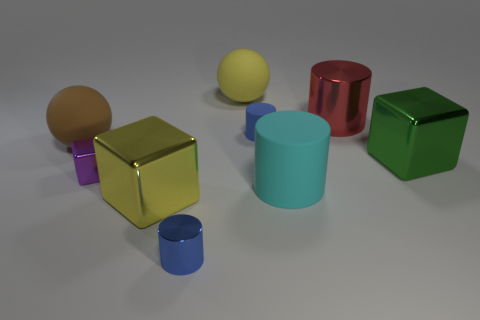Subtract all green metal cubes. How many cubes are left? 2 Subtract all blue cylinders. How many cylinders are left? 2 Subtract 3 cylinders. How many cylinders are left? 1 Subtract all yellow cylinders. Subtract all blue cubes. How many cylinders are left? 4 Subtract all blue cubes. How many red balls are left? 0 Subtract all metal cylinders. Subtract all big metal things. How many objects are left? 4 Add 6 matte objects. How many matte objects are left? 10 Add 4 big yellow metallic objects. How many big yellow metallic objects exist? 5 Subtract 0 blue spheres. How many objects are left? 9 Subtract all cubes. How many objects are left? 6 